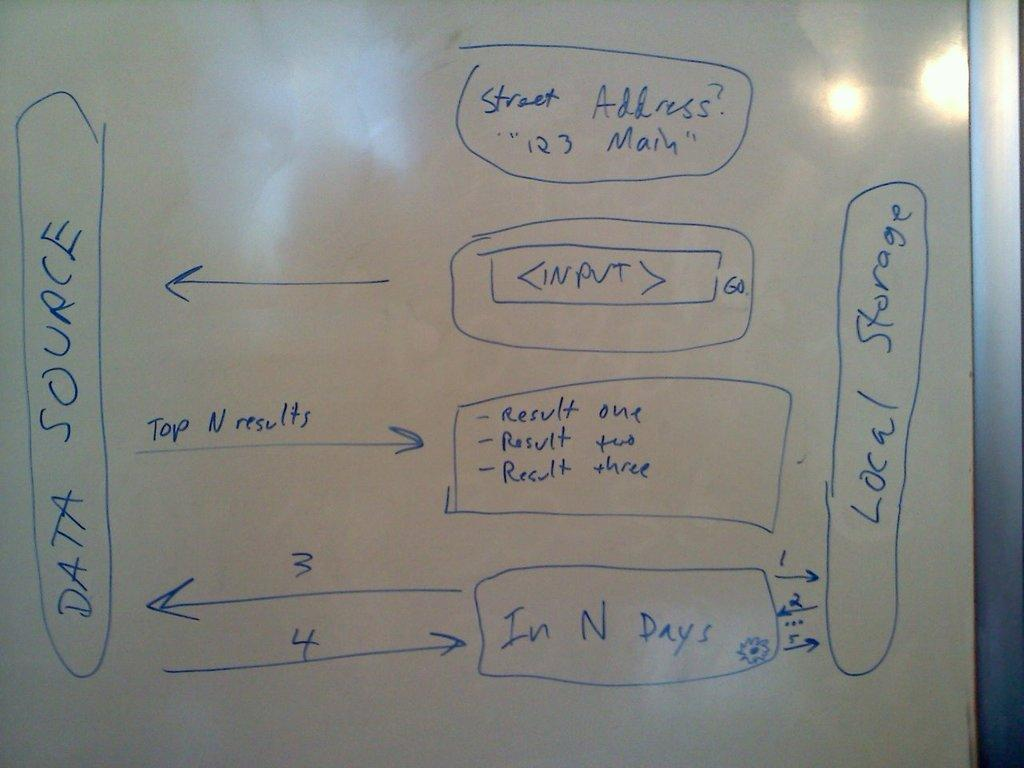What type of board is shown in the image? The board is a whiteboard. What can be seen on the whiteboard? There are letters on the board. What color are the letters on the whiteboard? The letters are blue in color. How many eggs are written on the whiteboard? There are no eggs visible on the whiteboard; it only has blue letters. 